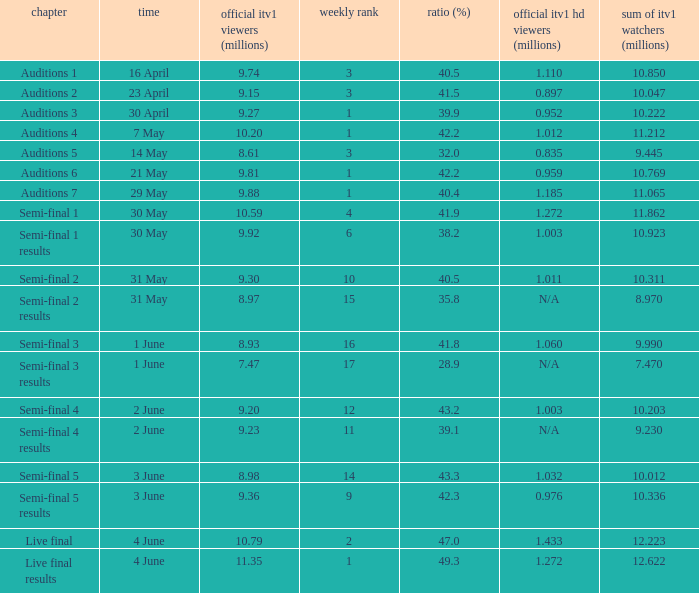What was the share (%) for the Semi-Final 2 episode?  40.5. 